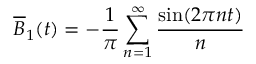Convert formula to latex. <formula><loc_0><loc_0><loc_500><loc_500>\overline { B } _ { 1 } ( t ) = - \frac { 1 } { \pi } \sum _ { n = 1 } ^ { \infty } \frac { \sin ( 2 \pi n t ) } { n }</formula> 